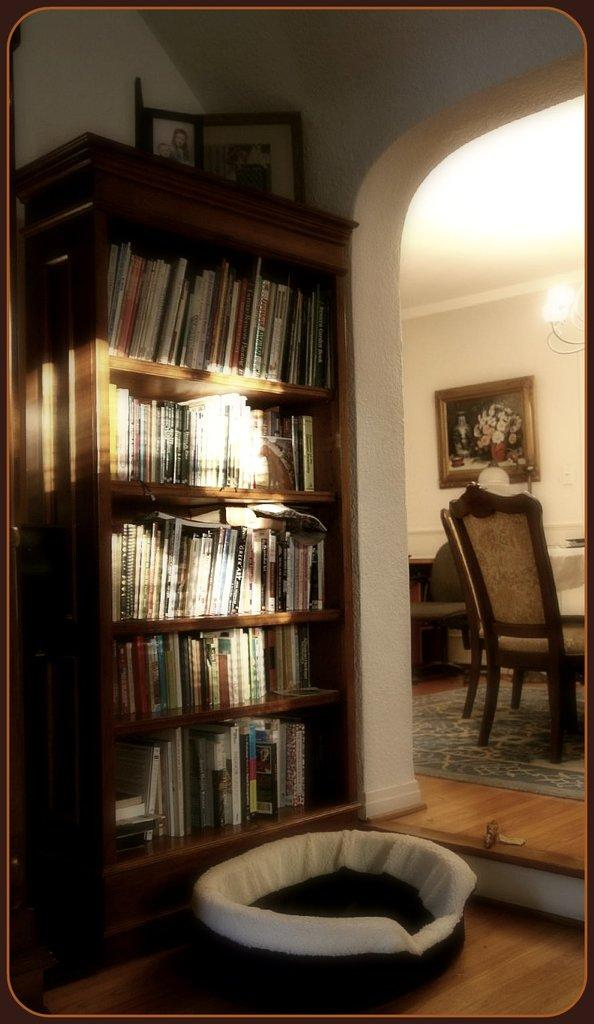What is on the rack in the image? There is a rack with books in the image. What is above the rack? There is a photo frame above the rack. What can be seen on the wall in the background? There is a frame on the wall in the background. What is visible in the background that provides light? There is a light in the background. What type of furniture is in the background? There is a chair in the background. How does the feeling of excitement manifest in the image? There is no indication of emotions or feelings in the image; it only shows a rack with books, a photo frame, a frame on the wall, a light, and a chair. What type of shoes are present in the image? There are no shoes visible in the image. 